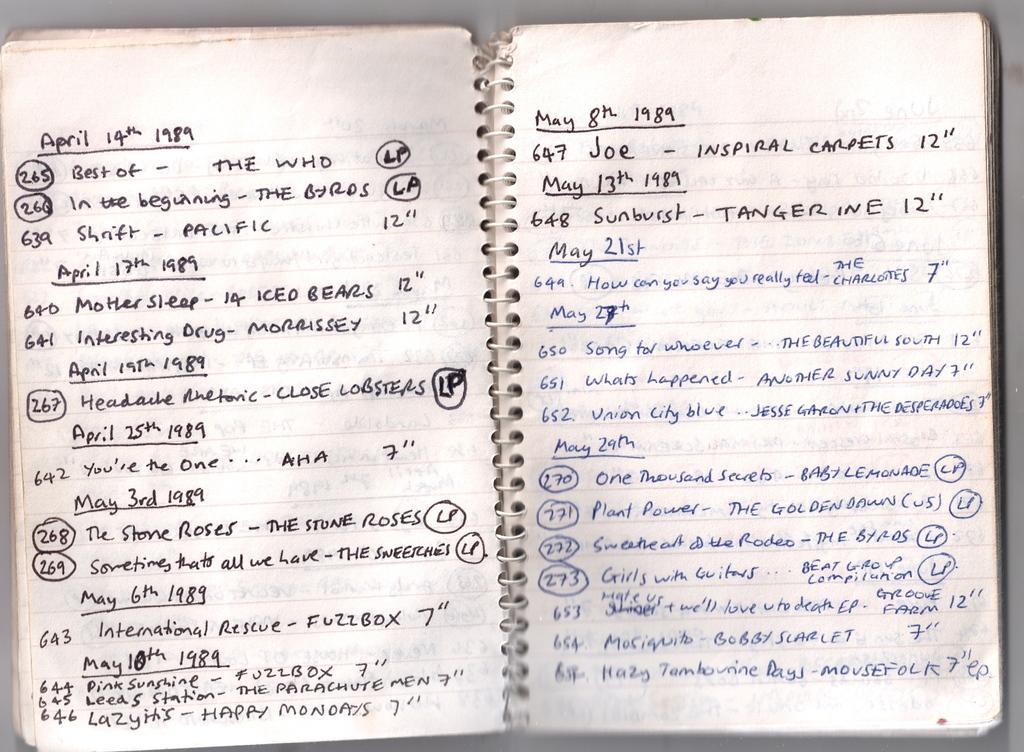In one or two sentences, can you explain what this image depicts? This looks like a book with the spring binding. I can see the letters and numbers written in the books. These are the papers. 